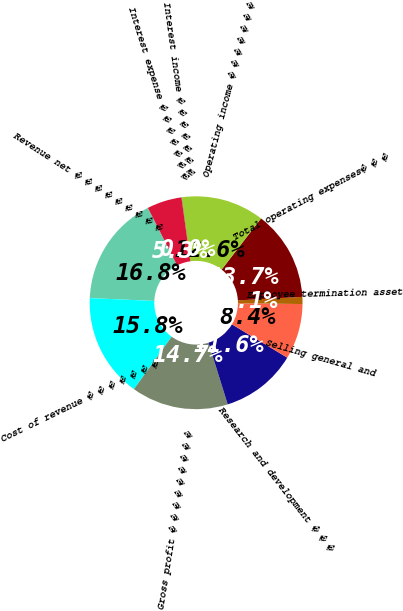<chart> <loc_0><loc_0><loc_500><loc_500><pie_chart><fcel>Revenue net � � � � � � � � �<fcel>Cost of revenue � � � � � � �<fcel>Gross profit � � � � � � � � �<fcel>Research and development � � �<fcel>Selling general and<fcel>Employee termination asset<fcel>Total operating expenses� � �<fcel>Operating income � � � � � � �<fcel>Interest income � � � � � � �<fcel>Interest expense � � � � � � �<nl><fcel>16.82%<fcel>15.77%<fcel>14.72%<fcel>11.57%<fcel>8.43%<fcel>1.08%<fcel>13.67%<fcel>12.62%<fcel>0.03%<fcel>5.28%<nl></chart> 